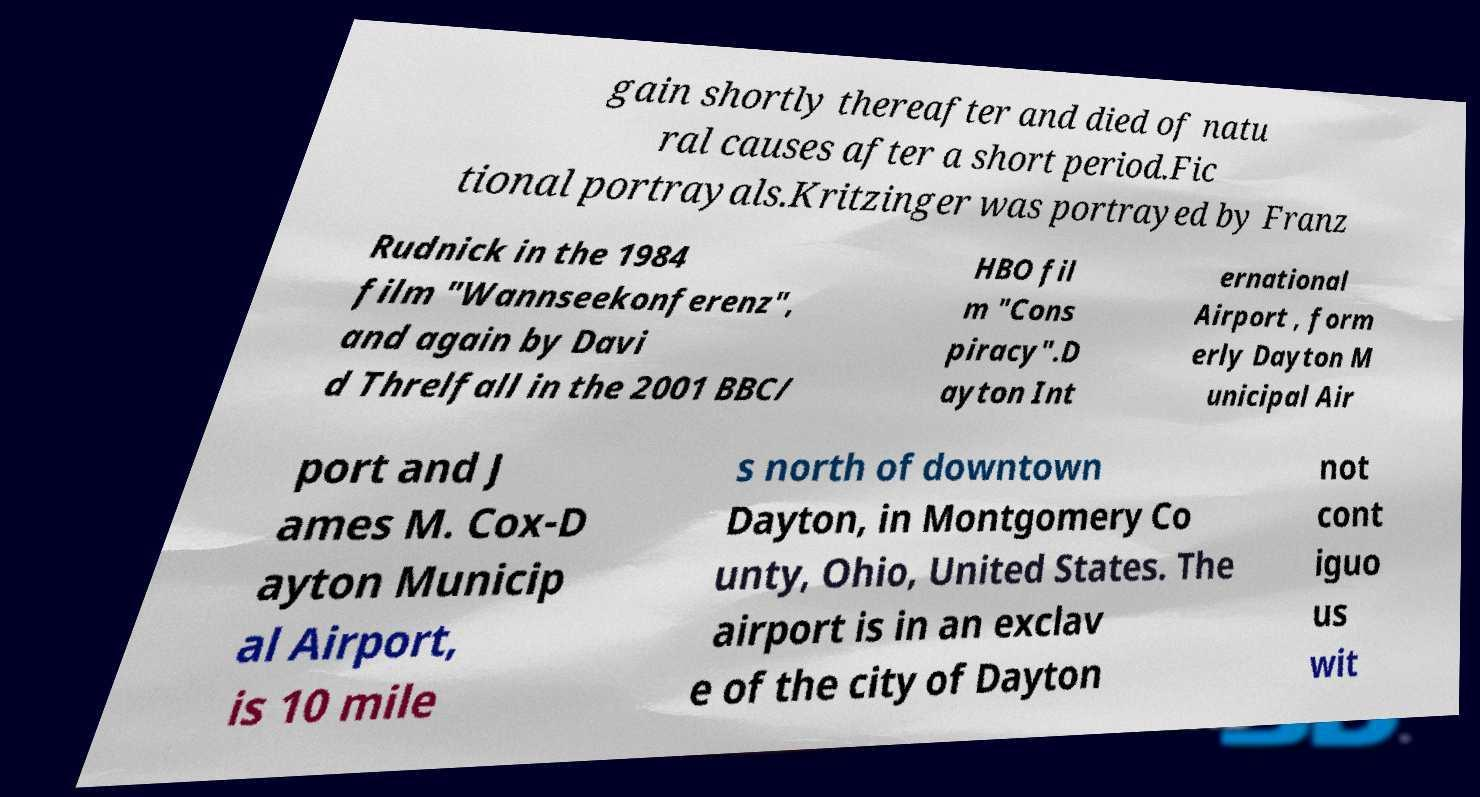Can you accurately transcribe the text from the provided image for me? gain shortly thereafter and died of natu ral causes after a short period.Fic tional portrayals.Kritzinger was portrayed by Franz Rudnick in the 1984 film "Wannseekonferenz", and again by Davi d Threlfall in the 2001 BBC/ HBO fil m "Cons piracy".D ayton Int ernational Airport , form erly Dayton M unicipal Air port and J ames M. Cox-D ayton Municip al Airport, is 10 mile s north of downtown Dayton, in Montgomery Co unty, Ohio, United States. The airport is in an exclav e of the city of Dayton not cont iguo us wit 